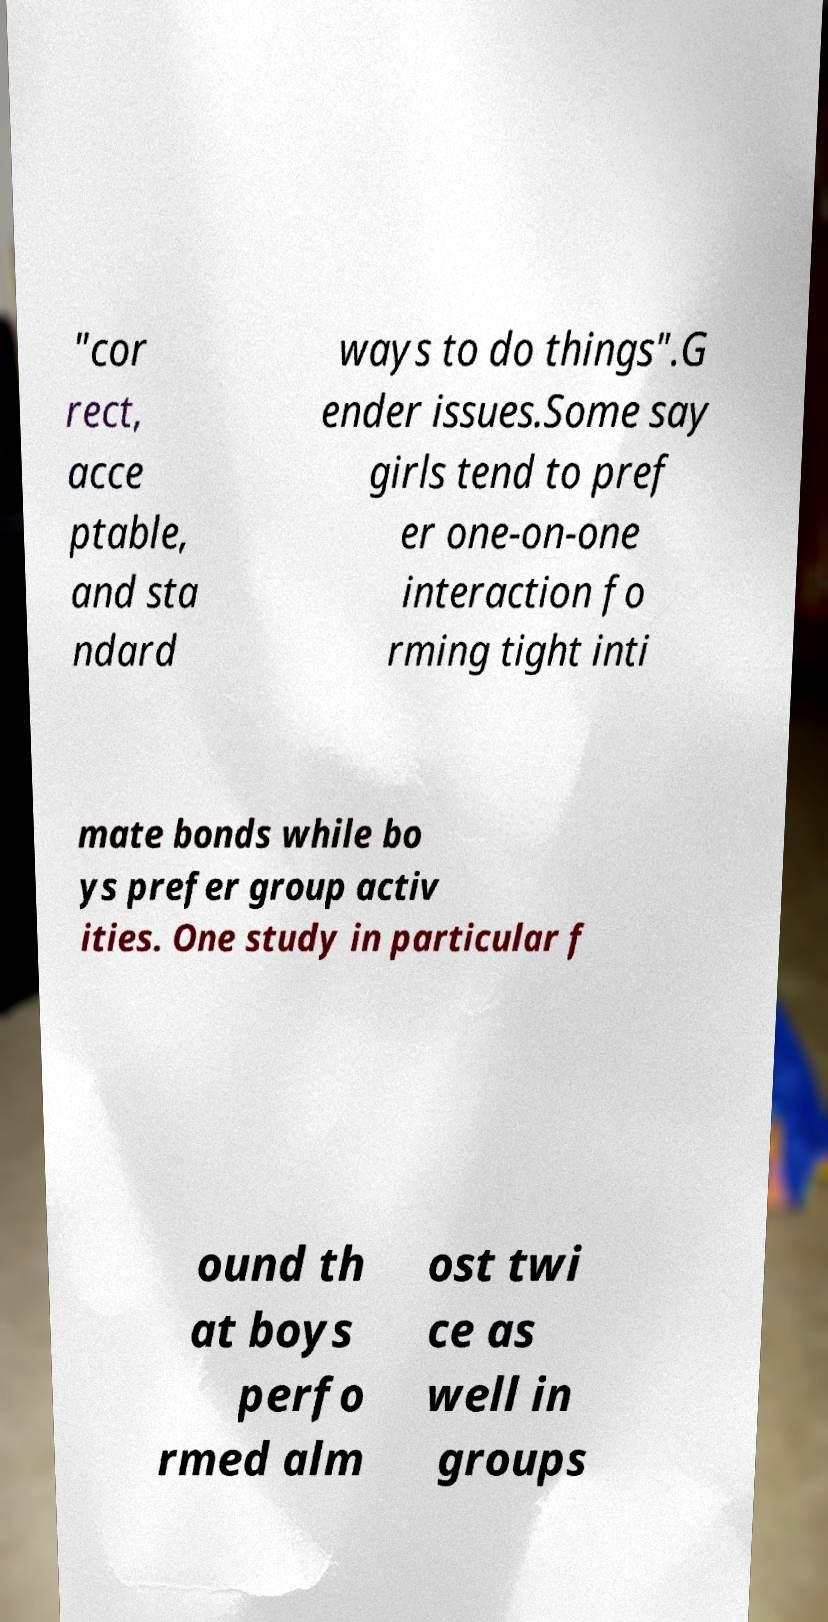Can you read and provide the text displayed in the image?This photo seems to have some interesting text. Can you extract and type it out for me? "cor rect, acce ptable, and sta ndard ways to do things".G ender issues.Some say girls tend to pref er one-on-one interaction fo rming tight inti mate bonds while bo ys prefer group activ ities. One study in particular f ound th at boys perfo rmed alm ost twi ce as well in groups 